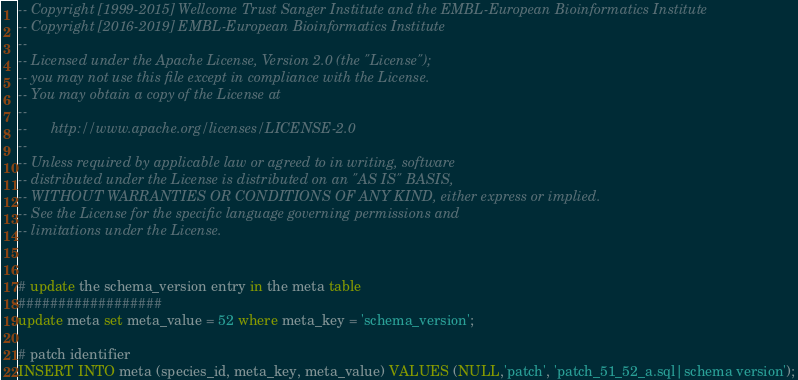Convert code to text. <code><loc_0><loc_0><loc_500><loc_500><_SQL_>-- Copyright [1999-2015] Wellcome Trust Sanger Institute and the EMBL-European Bioinformatics Institute
-- Copyright [2016-2019] EMBL-European Bioinformatics Institute
-- 
-- Licensed under the Apache License, Version 2.0 (the "License");
-- you may not use this file except in compliance with the License.
-- You may obtain a copy of the License at
-- 
--      http://www.apache.org/licenses/LICENSE-2.0
-- 
-- Unless required by applicable law or agreed to in writing, software
-- distributed under the License is distributed on an "AS IS" BASIS,
-- WITHOUT WARRANTIES OR CONDITIONS OF ANY KIND, either express or implied.
-- See the License for the specific language governing permissions and
-- limitations under the License.


# update the schema_version entry in the meta table
##################
update meta set meta_value = 52 where meta_key = 'schema_version';

# patch identifier
INSERT INTO meta (species_id, meta_key, meta_value) VALUES (NULL,'patch', 'patch_51_52_a.sql|schema version');
</code> 